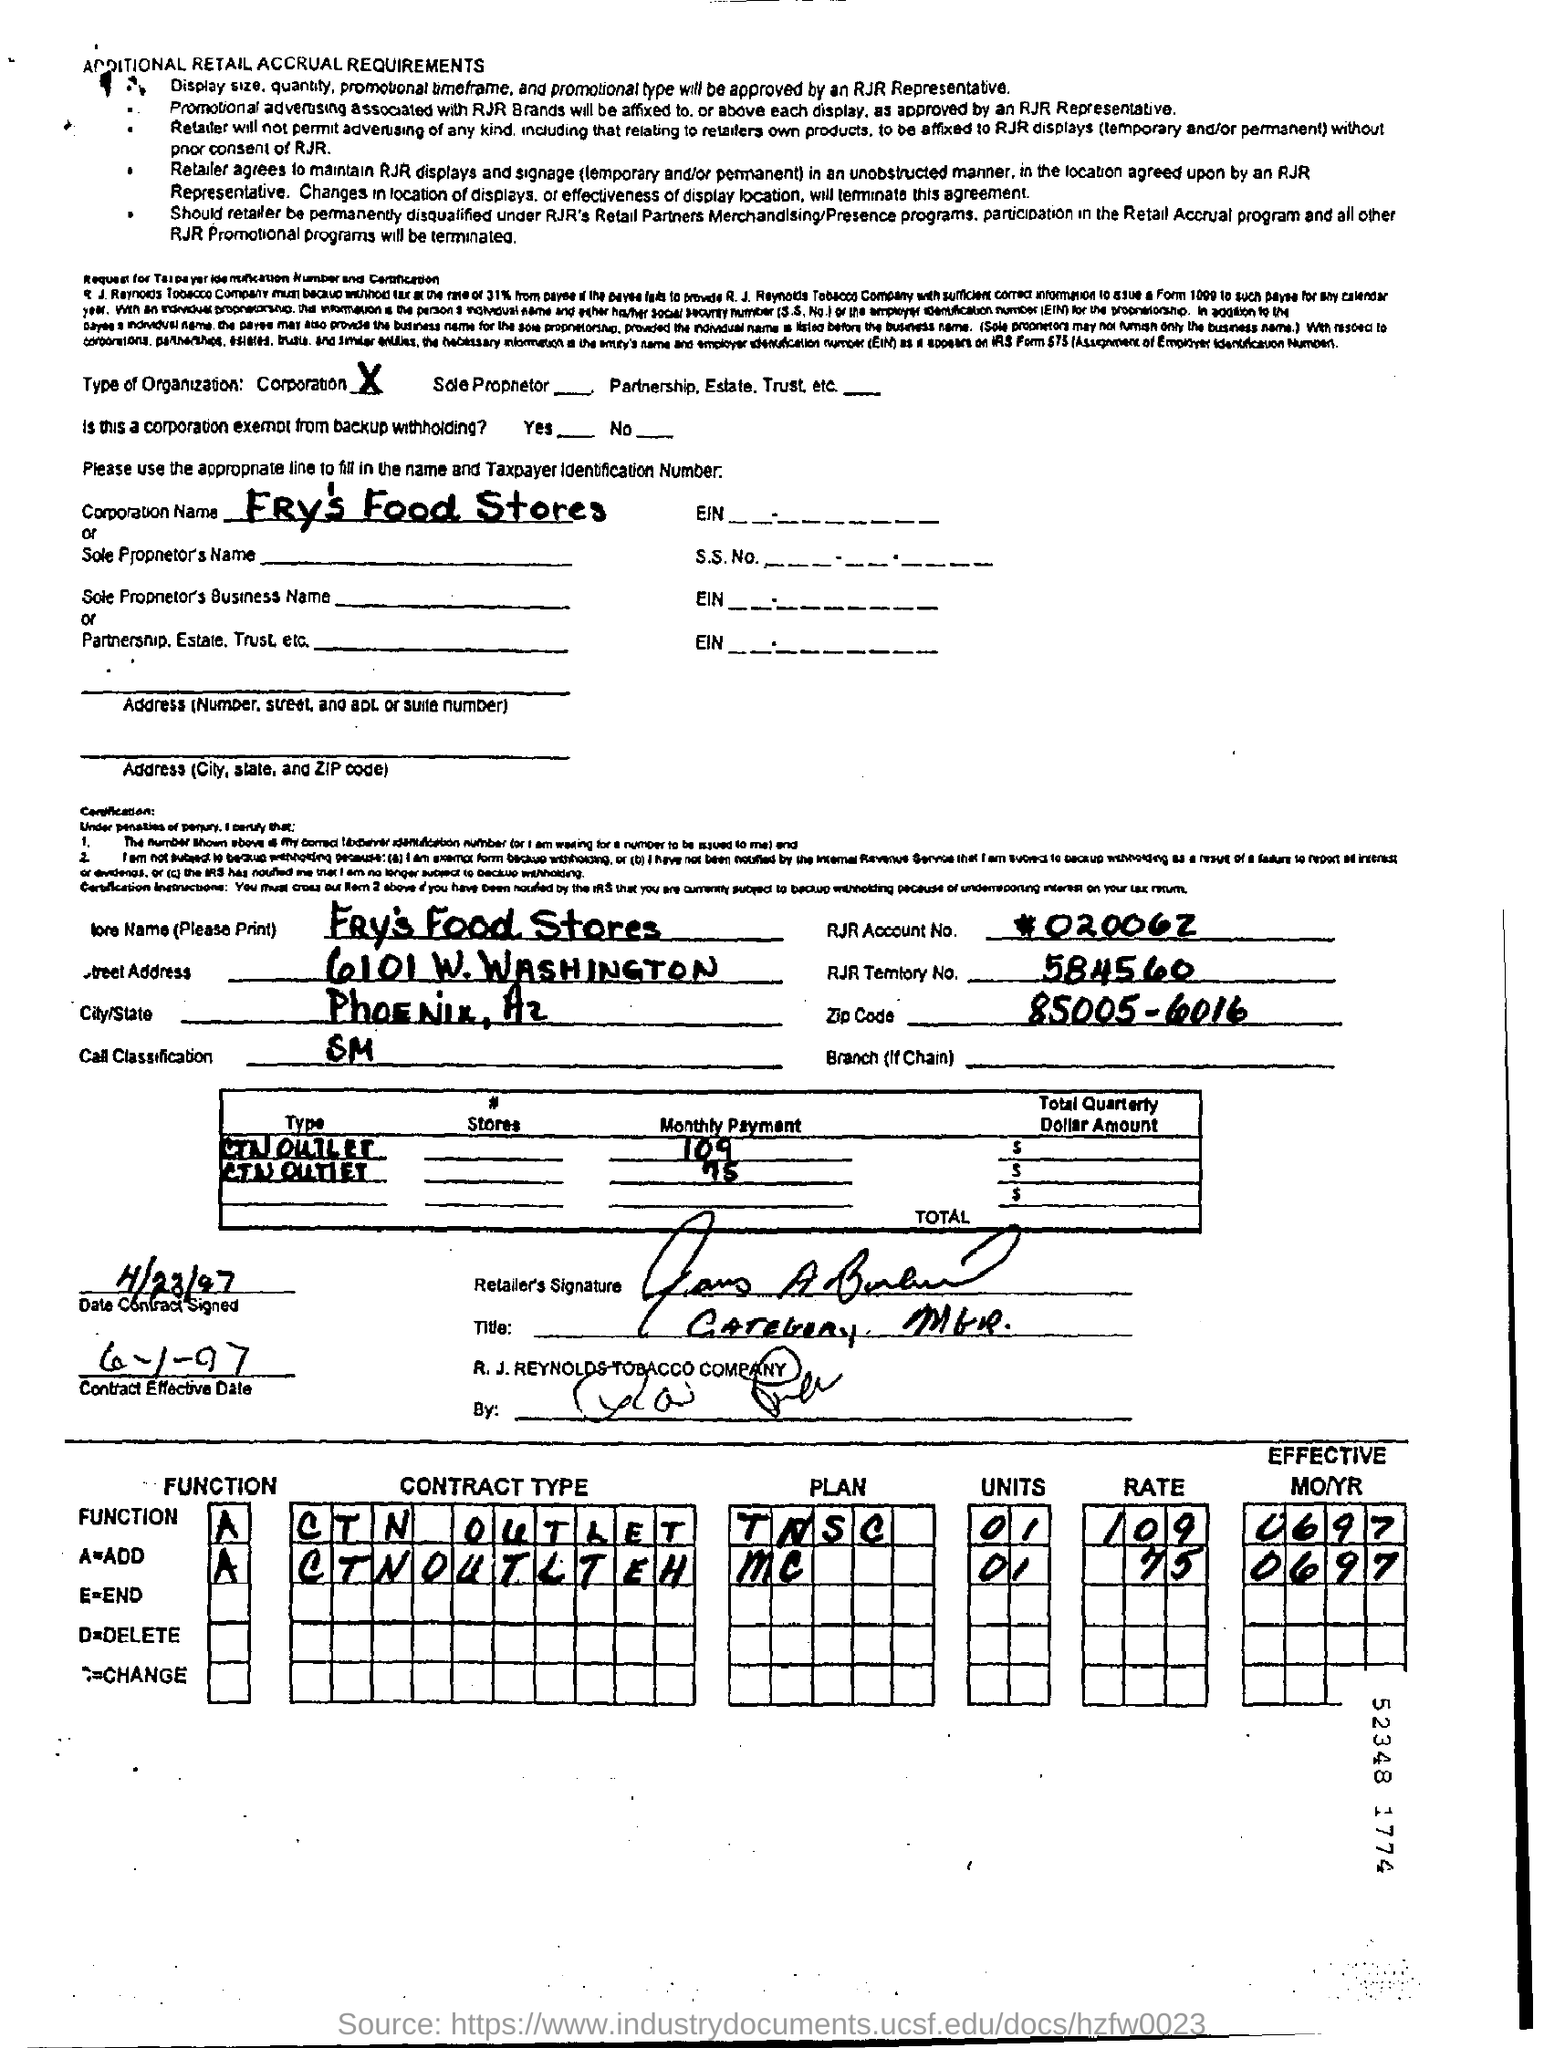What is the store name given in the document?
Offer a very short reply. Fry's food stores. What is the RJR territory No. mentioned in the document?
Give a very brief answer. 584560. What is the Zip Code given in the document?
Make the answer very short. 85005-6016. What is the Date of contract Signed?
Your response must be concise. 4/23/97. What is the contract effective date as per the document?
Keep it short and to the point. 6-1-97. 